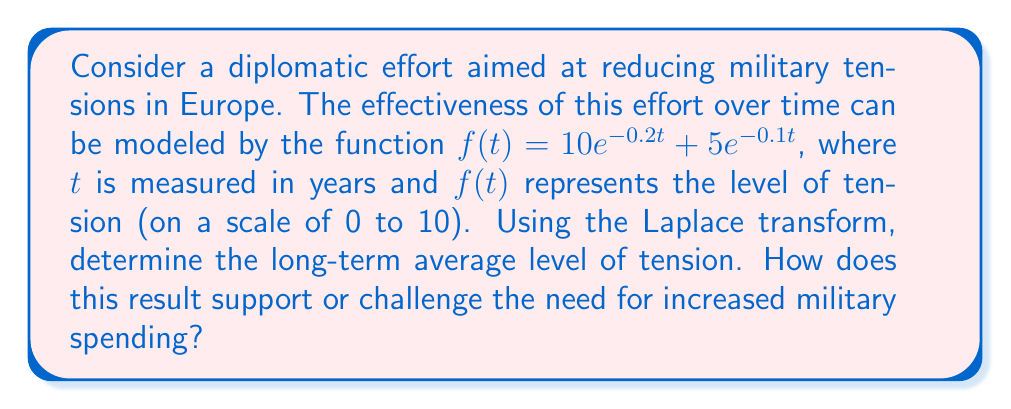Help me with this question. To solve this problem, we'll use the Laplace transform and the Final Value Theorem. Let's proceed step by step:

1) First, we need to find the Laplace transform of $f(t)$:

   $\mathcal{L}\{f(t)\} = \mathcal{L}\{10e^{-0.2t} + 5e^{-0.1t}\}$

2) Using the linearity property and the Laplace transform of exponential functions:

   $F(s) = \frac{10}{s+0.2} + \frac{5}{s+0.1}$

3) To find the long-term average, we can use the Final Value Theorem, which states that:

   $\lim_{t \to \infty} f(t) = \lim_{s \to 0} sF(s)$

4) Let's apply this theorem:

   $\lim_{s \to 0} s(\frac{10}{s+0.2} + \frac{5}{s+0.1})$

5) Simplifying:

   $\lim_{s \to 0} (\frac{10s}{s+0.2} + \frac{5s}{s+0.1})$

6) As $s$ approaches 0, this becomes:

   $\frac{10 \cdot 0}{0+0.2} + \frac{5 \cdot 0}{0+0.1} = 0 + 0 = 0$

7) Therefore, the long-term average level of tension approaches 0.

This result suggests that, in the long term, diplomatic efforts could effectively reduce tensions to a negligible level. From the perspective of a skeptical European citizen, this outcome challenges the need for increased military spending, as it indicates that diplomatic solutions can be effective in maintaining peace and stability.
Answer: The long-term average level of tension approaches 0, suggesting that diplomatic efforts could be highly effective in reducing military tensions over time. This result challenges the need for increased military spending from the perspective of a skeptical European citizen. 